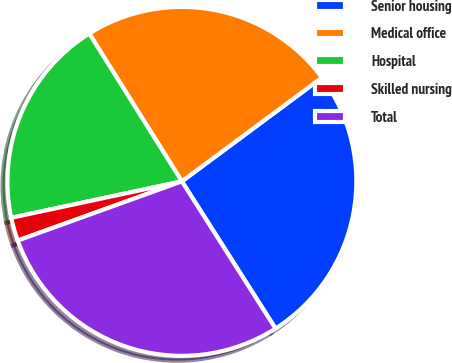Convert chart to OTSL. <chart><loc_0><loc_0><loc_500><loc_500><pie_chart><fcel>Senior housing<fcel>Medical office<fcel>Hospital<fcel>Skilled nursing<fcel>Total<nl><fcel>26.13%<fcel>23.76%<fcel>19.44%<fcel>2.16%<fcel>28.51%<nl></chart> 